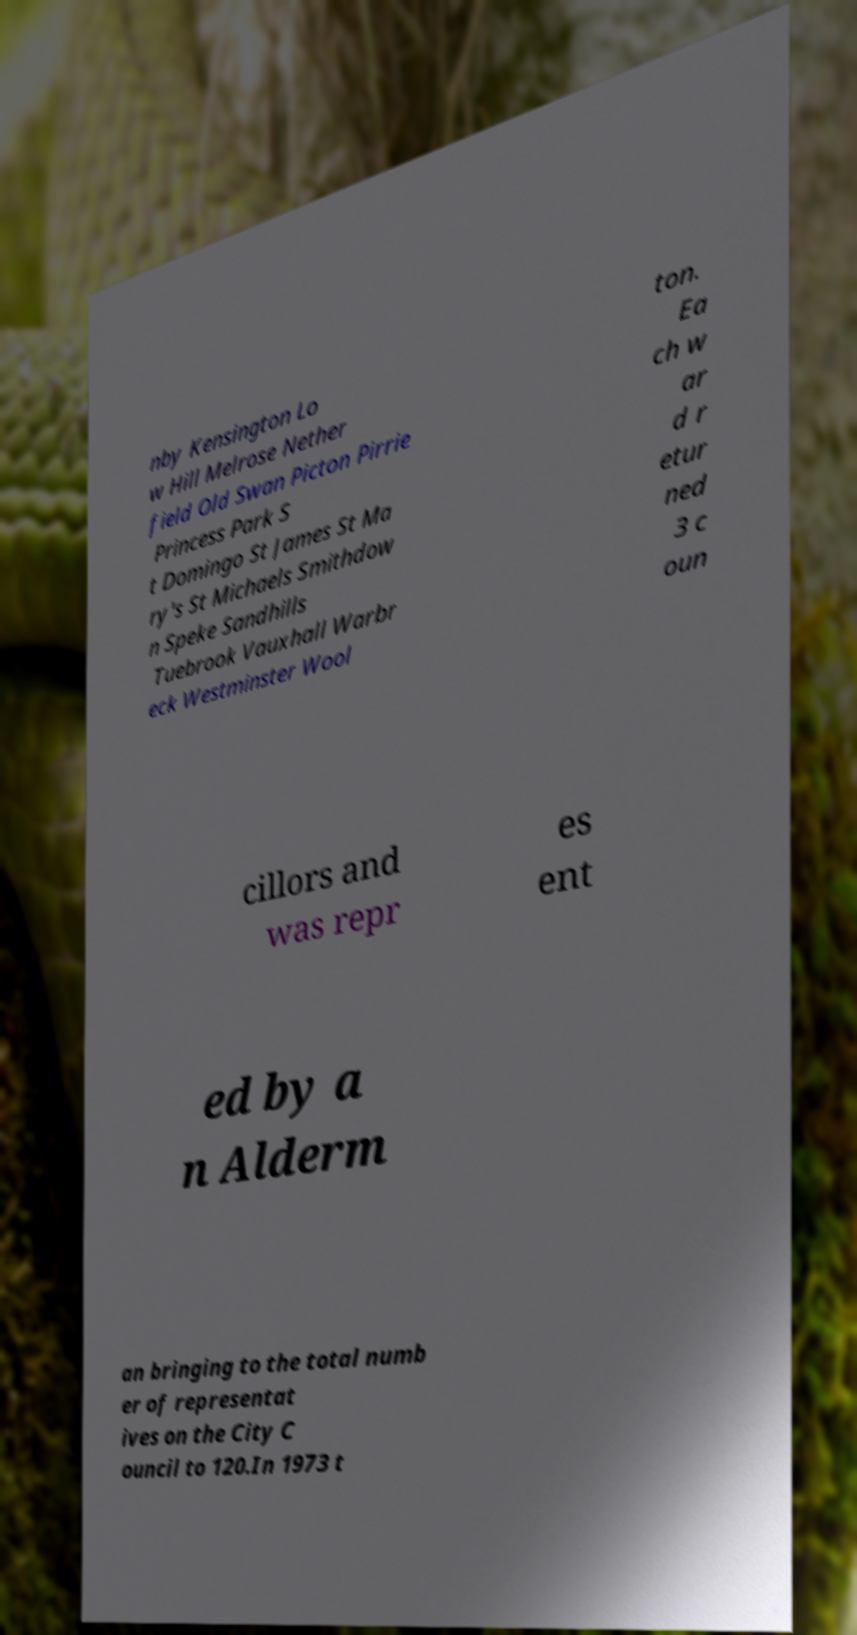Could you extract and type out the text from this image? nby Kensington Lo w Hill Melrose Nether field Old Swan Picton Pirrie Princess Park S t Domingo St James St Ma ry's St Michaels Smithdow n Speke Sandhills Tuebrook Vauxhall Warbr eck Westminster Wool ton. Ea ch w ar d r etur ned 3 c oun cillors and was repr es ent ed by a n Alderm an bringing to the total numb er of representat ives on the City C ouncil to 120.In 1973 t 